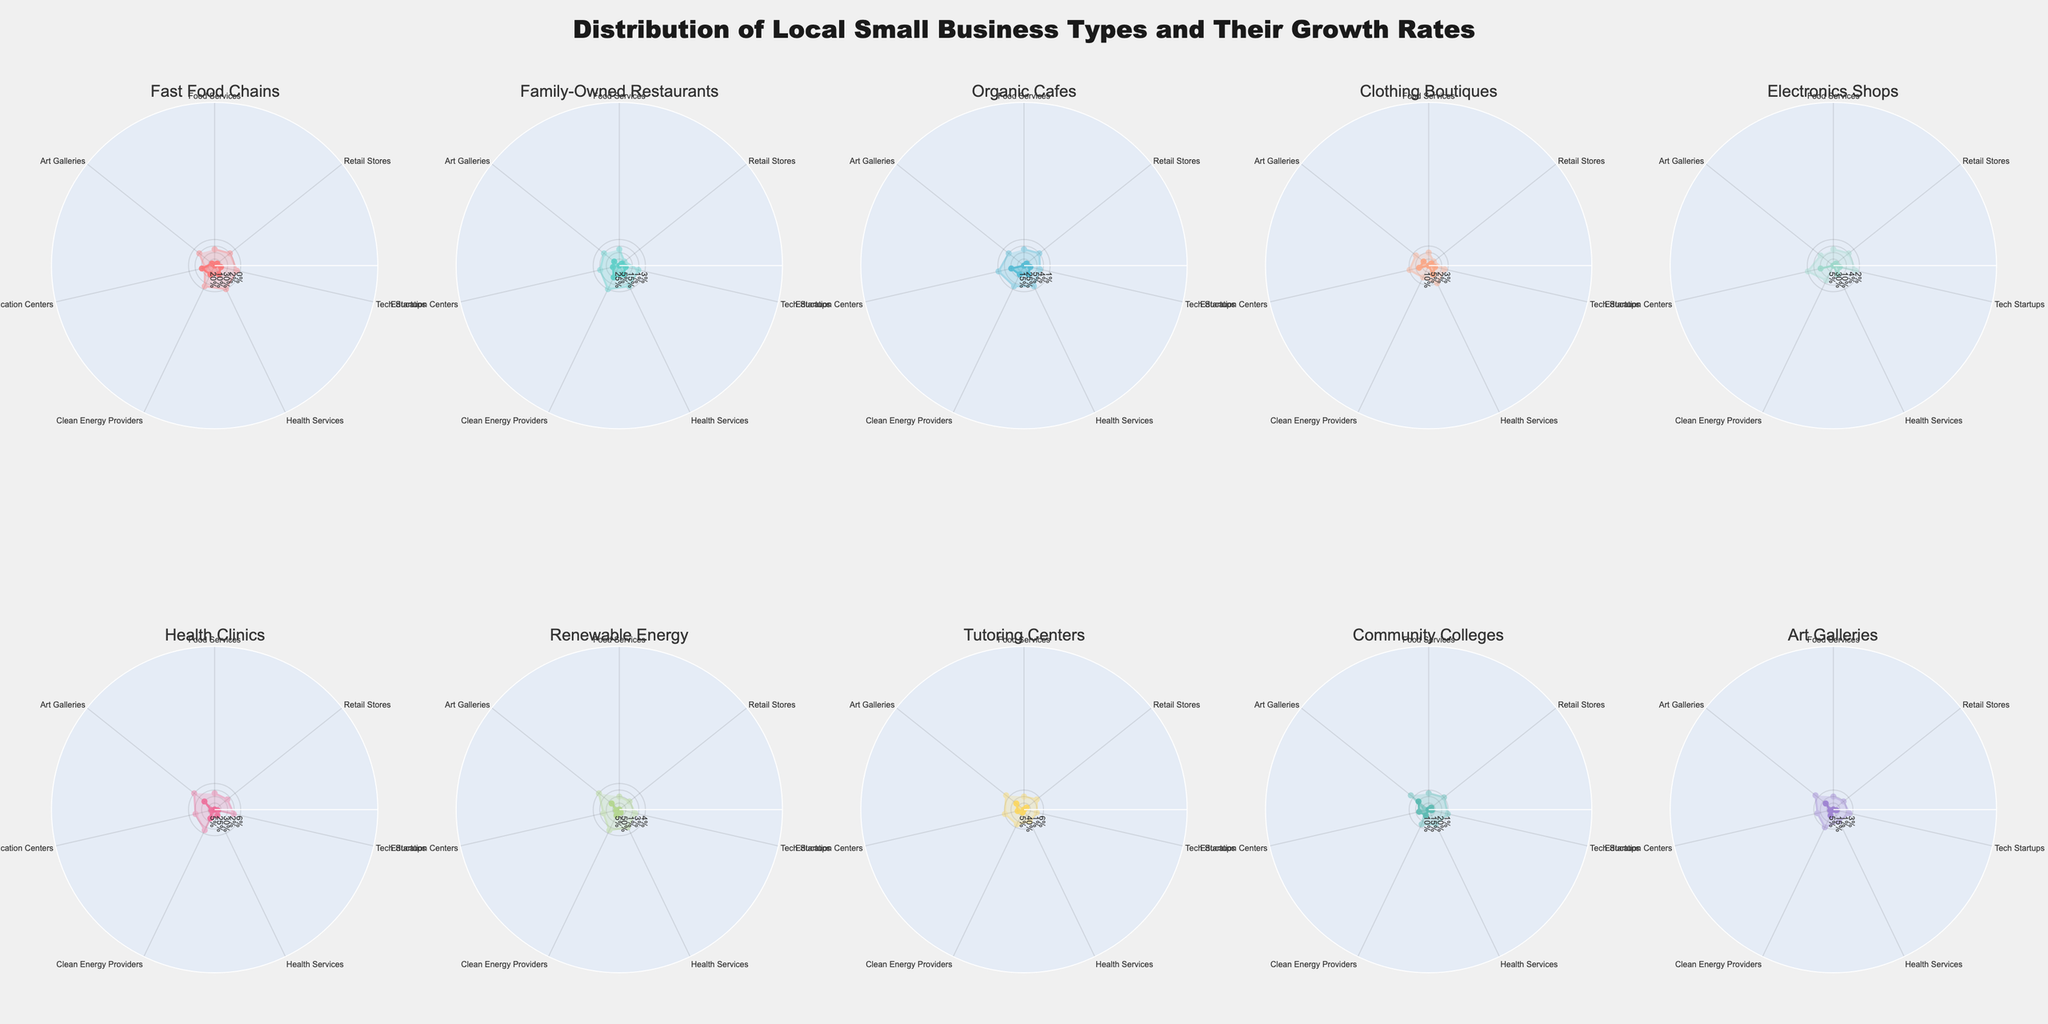What is the title of the figure? The title is always located at the top of the figure and it usually summarizes what the chart is about. Here, the title should be easy to find.
Answer: "Distribution of Local Small Business Types and Their Growth Rates" Which business type has the highest distribution in 'Health Services'? Look for the largest segment in the 'Health Services' category on the radar charts for all business types.
Answer: 'Health Clinics' What is the difference in growth rate between 'Electronics Shops' and 'Renewable Energy' in 'Tech Startups'? Locate the respective radar charts for 'Electronics Shops' and 'Renewable Energy', and identify the values in the 'Tech Startups' category, then subtract them: 6% - 2% = 4%.
Answer: 4% Which business type has the smallest distribution in 'Food Services'? Look for the smallest segment in the 'Food Services' category on the radar charts for all business types.
Answer: 'Art Galleries', 'Renewable Energy', 'Health Clinics', and 'Tutoring Centers' What is the total growth rate for 'Art Galleries' in all categories combined? Add up the growth rates in all categories for 'Art Galleries': 1% + 1% + 2% + 1% + 3% + 2% + 7% = 17%.
Answer: 17% Which business type has the highest combined distribution and growth rate in 'Education Centers'? Find the business type with the highest values when summing up distribution and growth rate in the 'Education Centers' category. 'Community Colleges' have a distribution of 35% and a growth rate of 5%, totaling to 40%, which is the highest.
Answer: 'Community Colleges' Which business type has a higher growth rate in 'Retail Stores', 'Family-Owned Restaurants' or 'Organic Cafes'? Look at the radar charts for 'Family-Owned Restaurants' and 'Organic Cafes', and compare their 'Retail Stores' growth rates, 5% and 4% respectively.
Answer: 'Family-Owned Restaurants' What is the average distribution rate for 'Food Services' across all business types? Identify the distribution rates for 'Food Services' across all business types and calculate the average: (20% + 25% + 15% + 10% + 5% + 5% + 5% + 5% + 10% + 5%) / 10 = 10.5%.
Answer: 10.5% Which business type shows the most growth in 'Clean Energy Providers'? Identify which radar chart segment is largest in the 'Clean Energy Providers' category for growth rates.
Answer: 'Renewable Energy' How many business types have a distribution rate of 5% in 'Tech Startups'? Count the segments that show a 5% distribution rate in the 'Tech Startups' category across all radar charts.
Answer: 5 